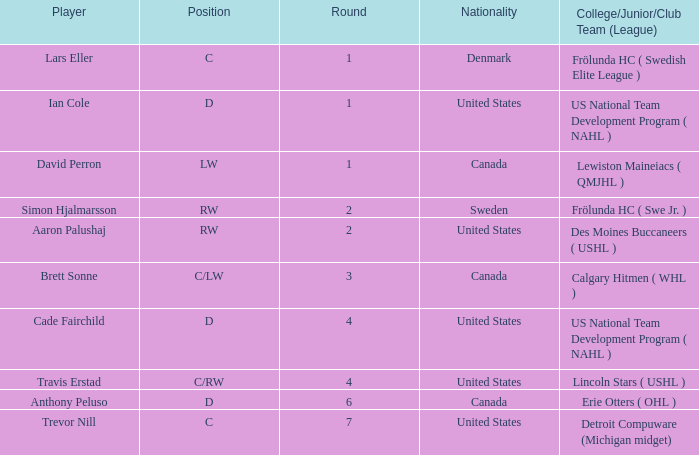Which college/junior/club team (league) did Brett Sonne play in? Calgary Hitmen ( WHL ). 